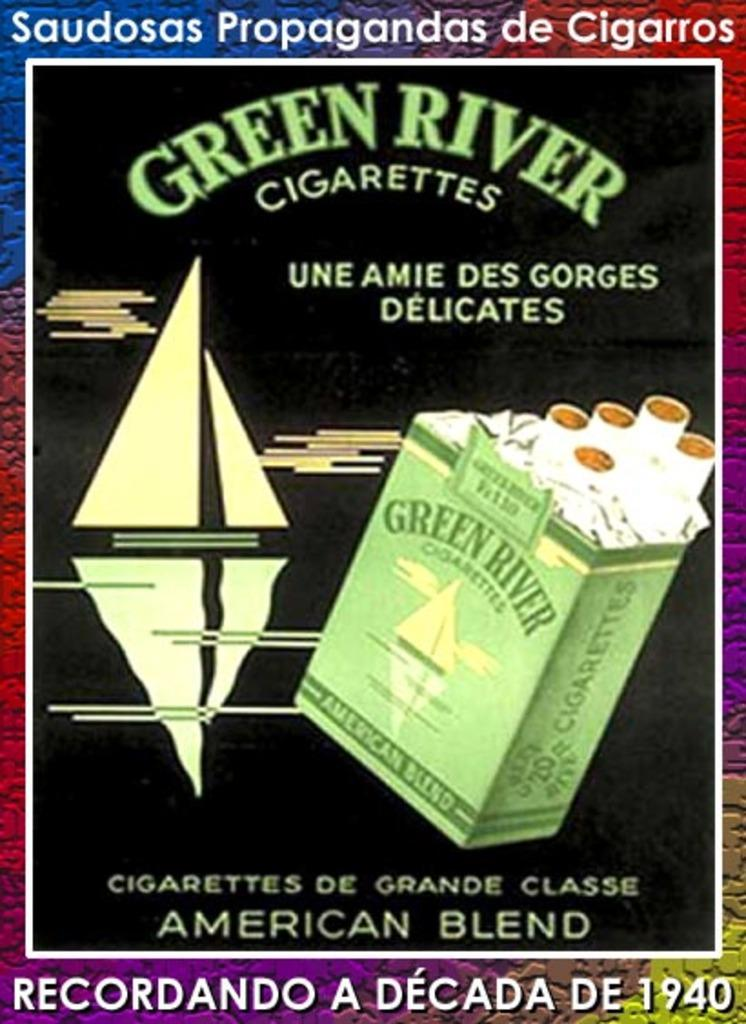What is featured in the image? There is a poster in the image. What is depicted on the poster? The poster contains pictures of cigarettes. Is there any text on the poster? Yes, there is text on the poster. How many crates of tomatoes are visible in the image? There are no crates of tomatoes present in the image; it features a poster with pictures of cigarettes. Is there a cook preparing a meal in the image? There is no cook or meal preparation visible in the image; it features a poster with pictures of cigarettes. 